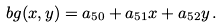Convert formula to latex. <formula><loc_0><loc_0><loc_500><loc_500>b g ( x , y ) = a _ { 5 0 } + a _ { 5 1 } x + a _ { 5 2 } y \, .</formula> 